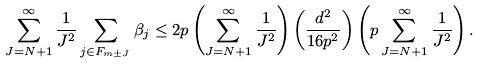Convert formula to latex. <formula><loc_0><loc_0><loc_500><loc_500>\sum _ { J = N + 1 } ^ { \infty } \frac { 1 } { J ^ { 2 } } \sum _ { j \in F _ { m \pm J } } \beta _ { j } \leq 2 p \left ( \sum _ { J = N + 1 } ^ { \infty } \frac { 1 } { J ^ { 2 } } \right ) \left ( \frac { d ^ { 2 } } { 1 6 p ^ { 2 } } \right ) \left ( p \sum _ { J = N + 1 } ^ { \infty } \frac { 1 } { J ^ { 2 } } \right ) .</formula> 